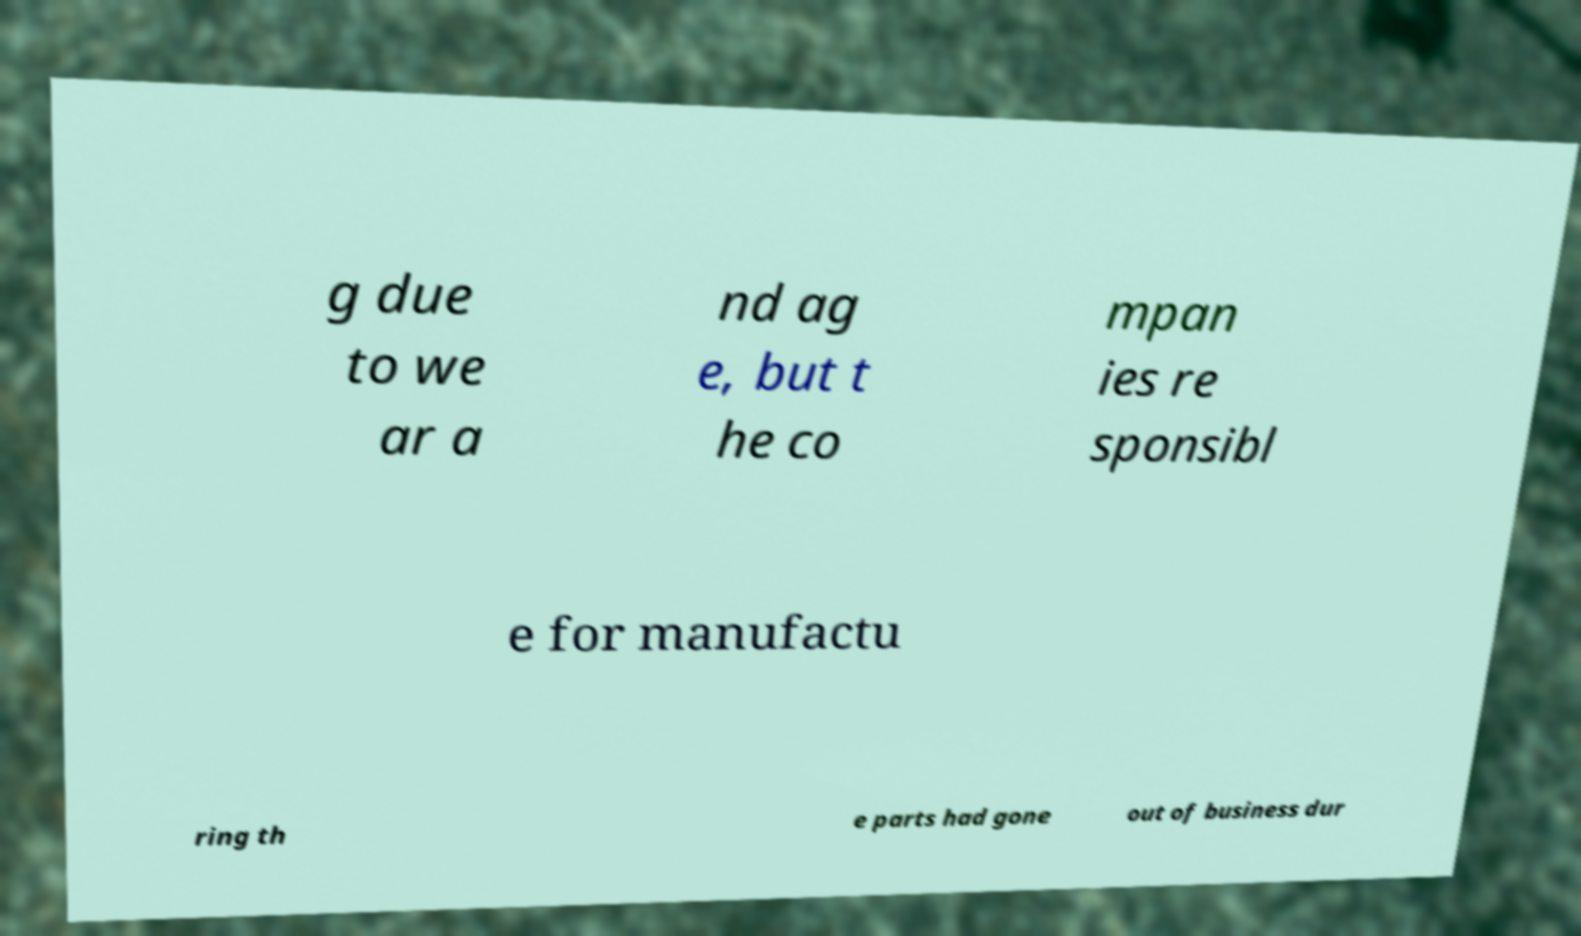I need the written content from this picture converted into text. Can you do that? g due to we ar a nd ag e, but t he co mpan ies re sponsibl e for manufactu ring th e parts had gone out of business dur 